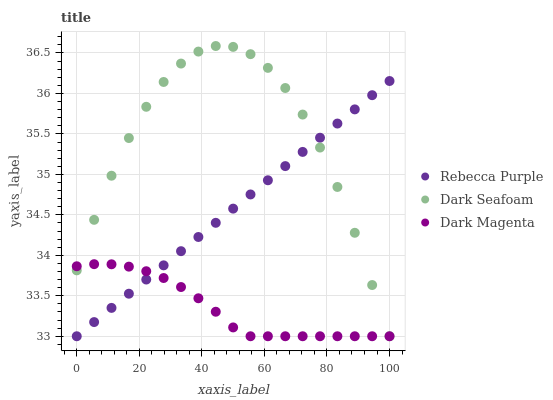Does Dark Magenta have the minimum area under the curve?
Answer yes or no. Yes. Does Dark Seafoam have the maximum area under the curve?
Answer yes or no. Yes. Does Rebecca Purple have the minimum area under the curve?
Answer yes or no. No. Does Rebecca Purple have the maximum area under the curve?
Answer yes or no. No. Is Rebecca Purple the smoothest?
Answer yes or no. Yes. Is Dark Seafoam the roughest?
Answer yes or no. Yes. Is Dark Magenta the smoothest?
Answer yes or no. No. Is Dark Magenta the roughest?
Answer yes or no. No. Does Dark Seafoam have the lowest value?
Answer yes or no. Yes. Does Dark Seafoam have the highest value?
Answer yes or no. Yes. Does Rebecca Purple have the highest value?
Answer yes or no. No. Does Rebecca Purple intersect Dark Magenta?
Answer yes or no. Yes. Is Rebecca Purple less than Dark Magenta?
Answer yes or no. No. Is Rebecca Purple greater than Dark Magenta?
Answer yes or no. No. 